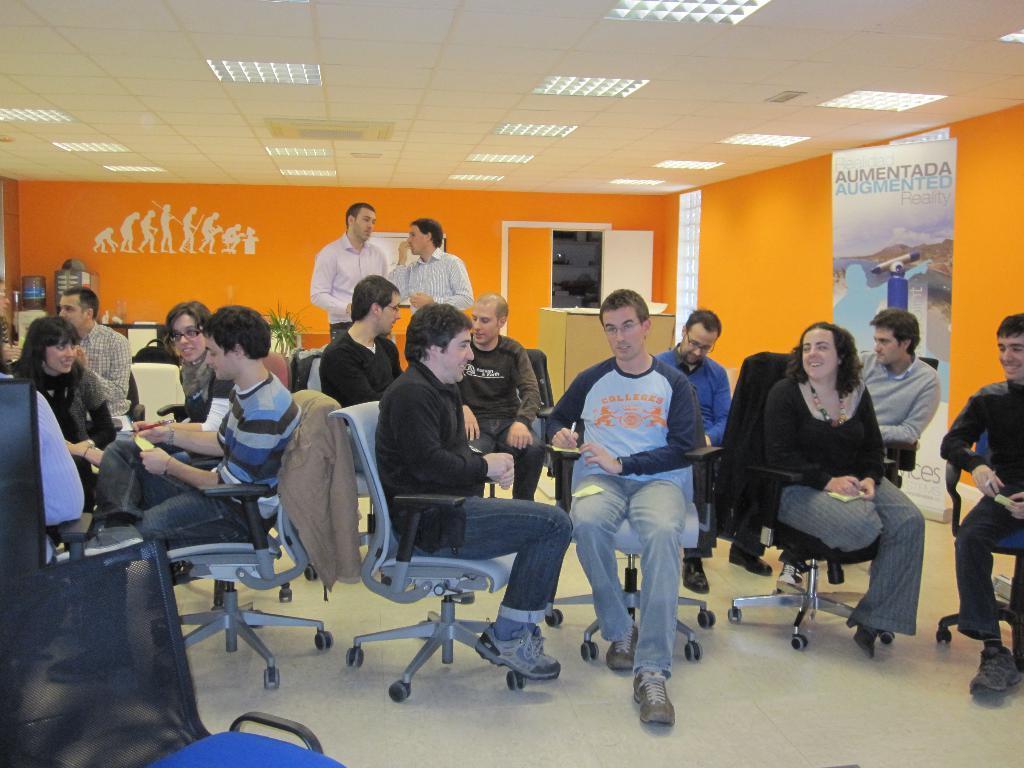Please provide a concise description of this image. In the image I can see some people who are sitting on the chairs and also I can see two other people who are standing and a poster to the side. 